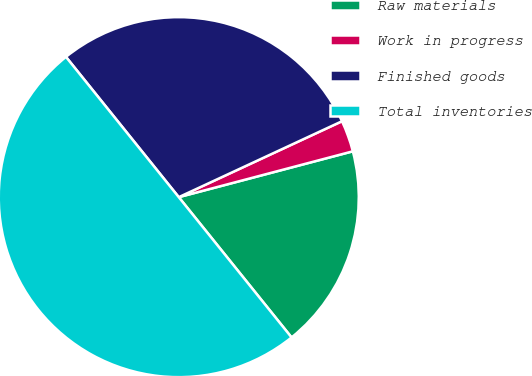<chart> <loc_0><loc_0><loc_500><loc_500><pie_chart><fcel>Raw materials<fcel>Work in progress<fcel>Finished goods<fcel>Total inventories<nl><fcel>18.32%<fcel>2.83%<fcel>28.85%<fcel>50.0%<nl></chart> 